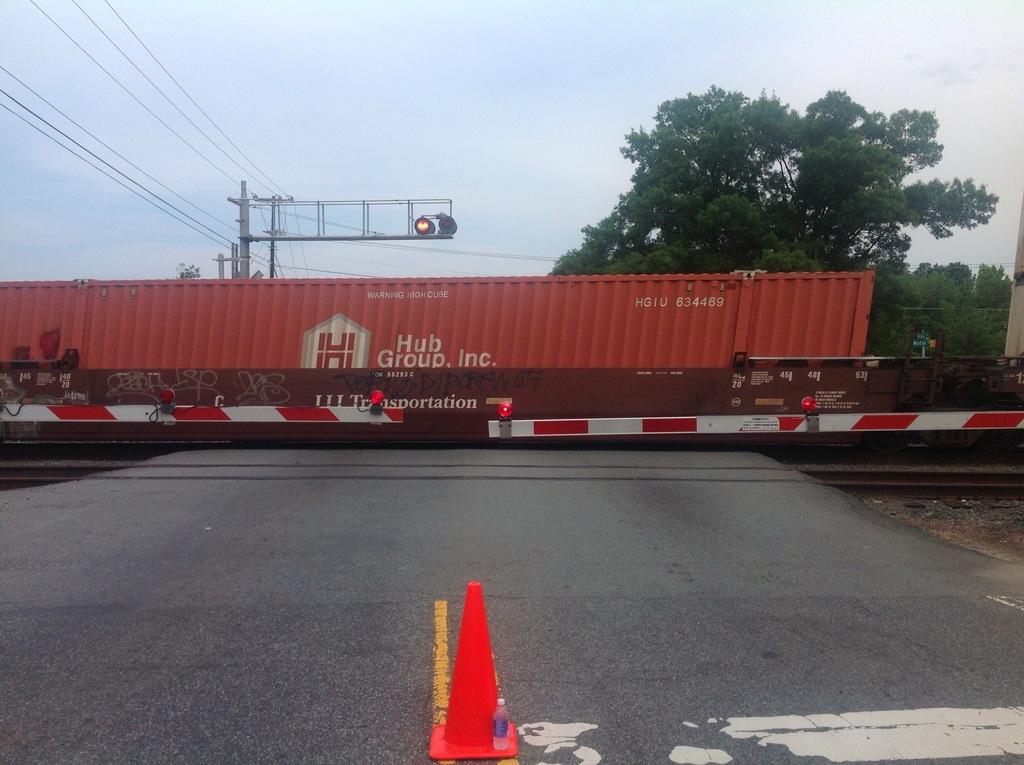Could you give a brief overview of what you see in this image? In this picture there is a container on the train. There is a train on the railway track. In the foreground there are poles. At the back there is a pole, there are wires and lights on the pole and there are trees. At the top there is sky. At the bottom there is a road. In the foreground there is an object on the road. 